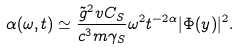<formula> <loc_0><loc_0><loc_500><loc_500>\alpha ( \omega , t ) \simeq \frac { \tilde { g } ^ { 2 } v C _ { S } } { c ^ { 3 } m \gamma _ { S } } \omega ^ { 2 } t ^ { - 2 \alpha } | \Phi ( y ) | ^ { 2 } .</formula> 